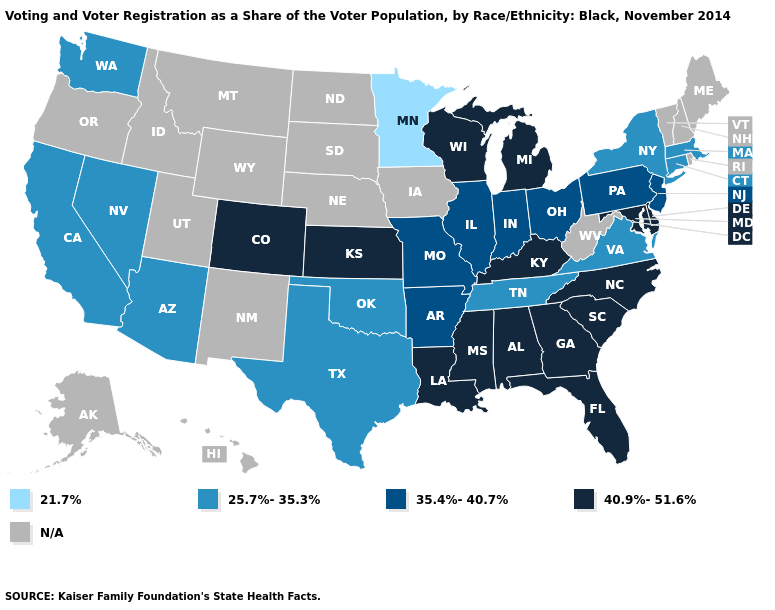What is the lowest value in the MidWest?
Give a very brief answer. 21.7%. How many symbols are there in the legend?
Short answer required. 5. What is the value of Mississippi?
Answer briefly. 40.9%-51.6%. Name the states that have a value in the range 35.4%-40.7%?
Keep it brief. Arkansas, Illinois, Indiana, Missouri, New Jersey, Ohio, Pennsylvania. What is the value of Rhode Island?
Be succinct. N/A. What is the lowest value in the West?
Write a very short answer. 25.7%-35.3%. Which states have the lowest value in the Northeast?
Write a very short answer. Connecticut, Massachusetts, New York. What is the highest value in states that border Nebraska?
Quick response, please. 40.9%-51.6%. What is the value of New Mexico?
Keep it brief. N/A. What is the lowest value in states that border Connecticut?
Answer briefly. 25.7%-35.3%. What is the highest value in the Northeast ?
Quick response, please. 35.4%-40.7%. What is the value of Kentucky?
Write a very short answer. 40.9%-51.6%. Name the states that have a value in the range 40.9%-51.6%?
Keep it brief. Alabama, Colorado, Delaware, Florida, Georgia, Kansas, Kentucky, Louisiana, Maryland, Michigan, Mississippi, North Carolina, South Carolina, Wisconsin. Name the states that have a value in the range 21.7%?
Be succinct. Minnesota. 